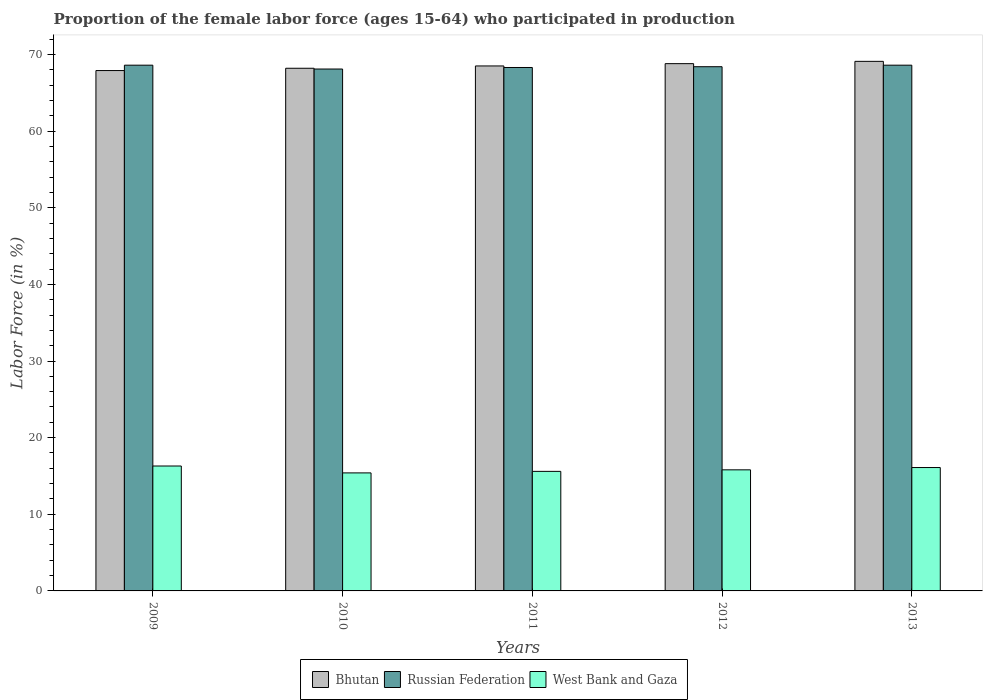How many different coloured bars are there?
Your answer should be compact. 3. How many groups of bars are there?
Your answer should be very brief. 5. How many bars are there on the 1st tick from the right?
Your response must be concise. 3. In how many cases, is the number of bars for a given year not equal to the number of legend labels?
Ensure brevity in your answer.  0. What is the proportion of the female labor force who participated in production in Russian Federation in 2012?
Provide a succinct answer. 68.4. Across all years, what is the maximum proportion of the female labor force who participated in production in Bhutan?
Your answer should be compact. 69.1. Across all years, what is the minimum proportion of the female labor force who participated in production in Russian Federation?
Give a very brief answer. 68.1. In which year was the proportion of the female labor force who participated in production in Russian Federation maximum?
Provide a succinct answer. 2009. In which year was the proportion of the female labor force who participated in production in West Bank and Gaza minimum?
Make the answer very short. 2010. What is the total proportion of the female labor force who participated in production in Russian Federation in the graph?
Offer a terse response. 342. What is the difference between the proportion of the female labor force who participated in production in Bhutan in 2011 and that in 2013?
Provide a short and direct response. -0.6. What is the difference between the proportion of the female labor force who participated in production in Bhutan in 2011 and the proportion of the female labor force who participated in production in West Bank and Gaza in 2013?
Make the answer very short. 52.4. What is the average proportion of the female labor force who participated in production in West Bank and Gaza per year?
Provide a short and direct response. 15.84. In the year 2009, what is the difference between the proportion of the female labor force who participated in production in West Bank and Gaza and proportion of the female labor force who participated in production in Russian Federation?
Make the answer very short. -52.3. What is the ratio of the proportion of the female labor force who participated in production in West Bank and Gaza in 2009 to that in 2010?
Provide a succinct answer. 1.06. Is the proportion of the female labor force who participated in production in Russian Federation in 2010 less than that in 2013?
Offer a very short reply. Yes. What is the difference between the highest and the second highest proportion of the female labor force who participated in production in West Bank and Gaza?
Keep it short and to the point. 0.2. What is the difference between the highest and the lowest proportion of the female labor force who participated in production in Russian Federation?
Make the answer very short. 0.5. What does the 3rd bar from the left in 2011 represents?
Ensure brevity in your answer.  West Bank and Gaza. What does the 3rd bar from the right in 2012 represents?
Your answer should be compact. Bhutan. Is it the case that in every year, the sum of the proportion of the female labor force who participated in production in West Bank and Gaza and proportion of the female labor force who participated in production in Russian Federation is greater than the proportion of the female labor force who participated in production in Bhutan?
Your response must be concise. Yes. How many bars are there?
Give a very brief answer. 15. How many years are there in the graph?
Keep it short and to the point. 5. Are the values on the major ticks of Y-axis written in scientific E-notation?
Your answer should be compact. No. Does the graph contain any zero values?
Offer a terse response. No. Does the graph contain grids?
Make the answer very short. No. How many legend labels are there?
Give a very brief answer. 3. What is the title of the graph?
Give a very brief answer. Proportion of the female labor force (ages 15-64) who participated in production. What is the label or title of the Y-axis?
Provide a succinct answer. Labor Force (in %). What is the Labor Force (in %) of Bhutan in 2009?
Keep it short and to the point. 67.9. What is the Labor Force (in %) in Russian Federation in 2009?
Your answer should be compact. 68.6. What is the Labor Force (in %) of West Bank and Gaza in 2009?
Make the answer very short. 16.3. What is the Labor Force (in %) of Bhutan in 2010?
Your response must be concise. 68.2. What is the Labor Force (in %) of Russian Federation in 2010?
Your response must be concise. 68.1. What is the Labor Force (in %) of West Bank and Gaza in 2010?
Provide a succinct answer. 15.4. What is the Labor Force (in %) of Bhutan in 2011?
Provide a short and direct response. 68.5. What is the Labor Force (in %) of Russian Federation in 2011?
Your response must be concise. 68.3. What is the Labor Force (in %) in West Bank and Gaza in 2011?
Give a very brief answer. 15.6. What is the Labor Force (in %) of Bhutan in 2012?
Keep it short and to the point. 68.8. What is the Labor Force (in %) of Russian Federation in 2012?
Your answer should be compact. 68.4. What is the Labor Force (in %) of West Bank and Gaza in 2012?
Your answer should be very brief. 15.8. What is the Labor Force (in %) in Bhutan in 2013?
Give a very brief answer. 69.1. What is the Labor Force (in %) of Russian Federation in 2013?
Give a very brief answer. 68.6. What is the Labor Force (in %) of West Bank and Gaza in 2013?
Provide a succinct answer. 16.1. Across all years, what is the maximum Labor Force (in %) of Bhutan?
Your response must be concise. 69.1. Across all years, what is the maximum Labor Force (in %) of Russian Federation?
Your answer should be very brief. 68.6. Across all years, what is the maximum Labor Force (in %) of West Bank and Gaza?
Ensure brevity in your answer.  16.3. Across all years, what is the minimum Labor Force (in %) in Bhutan?
Give a very brief answer. 67.9. Across all years, what is the minimum Labor Force (in %) of Russian Federation?
Your answer should be compact. 68.1. Across all years, what is the minimum Labor Force (in %) in West Bank and Gaza?
Offer a terse response. 15.4. What is the total Labor Force (in %) of Bhutan in the graph?
Your response must be concise. 342.5. What is the total Labor Force (in %) in Russian Federation in the graph?
Keep it short and to the point. 342. What is the total Labor Force (in %) in West Bank and Gaza in the graph?
Provide a succinct answer. 79.2. What is the difference between the Labor Force (in %) in Bhutan in 2009 and that in 2010?
Provide a succinct answer. -0.3. What is the difference between the Labor Force (in %) in Russian Federation in 2009 and that in 2010?
Your answer should be compact. 0.5. What is the difference between the Labor Force (in %) of West Bank and Gaza in 2009 and that in 2010?
Your answer should be compact. 0.9. What is the difference between the Labor Force (in %) of Russian Federation in 2009 and that in 2011?
Provide a succinct answer. 0.3. What is the difference between the Labor Force (in %) of West Bank and Gaza in 2009 and that in 2011?
Provide a short and direct response. 0.7. What is the difference between the Labor Force (in %) of Bhutan in 2009 and that in 2012?
Your response must be concise. -0.9. What is the difference between the Labor Force (in %) in Russian Federation in 2009 and that in 2012?
Offer a very short reply. 0.2. What is the difference between the Labor Force (in %) in West Bank and Gaza in 2009 and that in 2013?
Provide a short and direct response. 0.2. What is the difference between the Labor Force (in %) in Bhutan in 2010 and that in 2012?
Offer a terse response. -0.6. What is the difference between the Labor Force (in %) in Russian Federation in 2010 and that in 2012?
Make the answer very short. -0.3. What is the difference between the Labor Force (in %) of Bhutan in 2010 and that in 2013?
Offer a terse response. -0.9. What is the difference between the Labor Force (in %) of Russian Federation in 2010 and that in 2013?
Make the answer very short. -0.5. What is the difference between the Labor Force (in %) in Bhutan in 2011 and that in 2012?
Your response must be concise. -0.3. What is the difference between the Labor Force (in %) in West Bank and Gaza in 2011 and that in 2012?
Your answer should be compact. -0.2. What is the difference between the Labor Force (in %) in Russian Federation in 2011 and that in 2013?
Keep it short and to the point. -0.3. What is the difference between the Labor Force (in %) of West Bank and Gaza in 2011 and that in 2013?
Provide a short and direct response. -0.5. What is the difference between the Labor Force (in %) of Bhutan in 2012 and that in 2013?
Your answer should be compact. -0.3. What is the difference between the Labor Force (in %) in Russian Federation in 2012 and that in 2013?
Offer a terse response. -0.2. What is the difference between the Labor Force (in %) of Bhutan in 2009 and the Labor Force (in %) of Russian Federation in 2010?
Ensure brevity in your answer.  -0.2. What is the difference between the Labor Force (in %) in Bhutan in 2009 and the Labor Force (in %) in West Bank and Gaza in 2010?
Offer a very short reply. 52.5. What is the difference between the Labor Force (in %) of Russian Federation in 2009 and the Labor Force (in %) of West Bank and Gaza in 2010?
Provide a short and direct response. 53.2. What is the difference between the Labor Force (in %) in Bhutan in 2009 and the Labor Force (in %) in Russian Federation in 2011?
Keep it short and to the point. -0.4. What is the difference between the Labor Force (in %) in Bhutan in 2009 and the Labor Force (in %) in West Bank and Gaza in 2011?
Offer a terse response. 52.3. What is the difference between the Labor Force (in %) in Bhutan in 2009 and the Labor Force (in %) in West Bank and Gaza in 2012?
Offer a terse response. 52.1. What is the difference between the Labor Force (in %) in Russian Federation in 2009 and the Labor Force (in %) in West Bank and Gaza in 2012?
Ensure brevity in your answer.  52.8. What is the difference between the Labor Force (in %) of Bhutan in 2009 and the Labor Force (in %) of West Bank and Gaza in 2013?
Give a very brief answer. 51.8. What is the difference between the Labor Force (in %) of Russian Federation in 2009 and the Labor Force (in %) of West Bank and Gaza in 2013?
Offer a very short reply. 52.5. What is the difference between the Labor Force (in %) in Bhutan in 2010 and the Labor Force (in %) in West Bank and Gaza in 2011?
Your answer should be very brief. 52.6. What is the difference between the Labor Force (in %) in Russian Federation in 2010 and the Labor Force (in %) in West Bank and Gaza in 2011?
Your answer should be very brief. 52.5. What is the difference between the Labor Force (in %) in Bhutan in 2010 and the Labor Force (in %) in Russian Federation in 2012?
Offer a terse response. -0.2. What is the difference between the Labor Force (in %) of Bhutan in 2010 and the Labor Force (in %) of West Bank and Gaza in 2012?
Your answer should be compact. 52.4. What is the difference between the Labor Force (in %) of Russian Federation in 2010 and the Labor Force (in %) of West Bank and Gaza in 2012?
Your answer should be compact. 52.3. What is the difference between the Labor Force (in %) of Bhutan in 2010 and the Labor Force (in %) of West Bank and Gaza in 2013?
Ensure brevity in your answer.  52.1. What is the difference between the Labor Force (in %) in Russian Federation in 2010 and the Labor Force (in %) in West Bank and Gaza in 2013?
Your answer should be compact. 52. What is the difference between the Labor Force (in %) of Bhutan in 2011 and the Labor Force (in %) of West Bank and Gaza in 2012?
Make the answer very short. 52.7. What is the difference between the Labor Force (in %) in Russian Federation in 2011 and the Labor Force (in %) in West Bank and Gaza in 2012?
Offer a very short reply. 52.5. What is the difference between the Labor Force (in %) of Bhutan in 2011 and the Labor Force (in %) of West Bank and Gaza in 2013?
Your answer should be very brief. 52.4. What is the difference between the Labor Force (in %) in Russian Federation in 2011 and the Labor Force (in %) in West Bank and Gaza in 2013?
Give a very brief answer. 52.2. What is the difference between the Labor Force (in %) of Bhutan in 2012 and the Labor Force (in %) of West Bank and Gaza in 2013?
Offer a very short reply. 52.7. What is the difference between the Labor Force (in %) in Russian Federation in 2012 and the Labor Force (in %) in West Bank and Gaza in 2013?
Offer a very short reply. 52.3. What is the average Labor Force (in %) of Bhutan per year?
Your response must be concise. 68.5. What is the average Labor Force (in %) of Russian Federation per year?
Make the answer very short. 68.4. What is the average Labor Force (in %) in West Bank and Gaza per year?
Give a very brief answer. 15.84. In the year 2009, what is the difference between the Labor Force (in %) of Bhutan and Labor Force (in %) of West Bank and Gaza?
Offer a terse response. 51.6. In the year 2009, what is the difference between the Labor Force (in %) of Russian Federation and Labor Force (in %) of West Bank and Gaza?
Ensure brevity in your answer.  52.3. In the year 2010, what is the difference between the Labor Force (in %) of Bhutan and Labor Force (in %) of West Bank and Gaza?
Provide a short and direct response. 52.8. In the year 2010, what is the difference between the Labor Force (in %) in Russian Federation and Labor Force (in %) in West Bank and Gaza?
Keep it short and to the point. 52.7. In the year 2011, what is the difference between the Labor Force (in %) in Bhutan and Labor Force (in %) in Russian Federation?
Offer a very short reply. 0.2. In the year 2011, what is the difference between the Labor Force (in %) of Bhutan and Labor Force (in %) of West Bank and Gaza?
Provide a short and direct response. 52.9. In the year 2011, what is the difference between the Labor Force (in %) of Russian Federation and Labor Force (in %) of West Bank and Gaza?
Ensure brevity in your answer.  52.7. In the year 2012, what is the difference between the Labor Force (in %) of Bhutan and Labor Force (in %) of West Bank and Gaza?
Offer a very short reply. 53. In the year 2012, what is the difference between the Labor Force (in %) in Russian Federation and Labor Force (in %) in West Bank and Gaza?
Offer a terse response. 52.6. In the year 2013, what is the difference between the Labor Force (in %) of Bhutan and Labor Force (in %) of Russian Federation?
Give a very brief answer. 0.5. In the year 2013, what is the difference between the Labor Force (in %) of Bhutan and Labor Force (in %) of West Bank and Gaza?
Give a very brief answer. 53. In the year 2013, what is the difference between the Labor Force (in %) of Russian Federation and Labor Force (in %) of West Bank and Gaza?
Offer a terse response. 52.5. What is the ratio of the Labor Force (in %) of Bhutan in 2009 to that in 2010?
Give a very brief answer. 1. What is the ratio of the Labor Force (in %) in Russian Federation in 2009 to that in 2010?
Your response must be concise. 1.01. What is the ratio of the Labor Force (in %) in West Bank and Gaza in 2009 to that in 2010?
Your answer should be very brief. 1.06. What is the ratio of the Labor Force (in %) in Bhutan in 2009 to that in 2011?
Offer a terse response. 0.99. What is the ratio of the Labor Force (in %) in Russian Federation in 2009 to that in 2011?
Offer a terse response. 1. What is the ratio of the Labor Force (in %) of West Bank and Gaza in 2009 to that in 2011?
Ensure brevity in your answer.  1.04. What is the ratio of the Labor Force (in %) in Bhutan in 2009 to that in 2012?
Ensure brevity in your answer.  0.99. What is the ratio of the Labor Force (in %) of West Bank and Gaza in 2009 to that in 2012?
Give a very brief answer. 1.03. What is the ratio of the Labor Force (in %) in Bhutan in 2009 to that in 2013?
Provide a succinct answer. 0.98. What is the ratio of the Labor Force (in %) of Russian Federation in 2009 to that in 2013?
Provide a short and direct response. 1. What is the ratio of the Labor Force (in %) of West Bank and Gaza in 2009 to that in 2013?
Your answer should be very brief. 1.01. What is the ratio of the Labor Force (in %) of Russian Federation in 2010 to that in 2011?
Ensure brevity in your answer.  1. What is the ratio of the Labor Force (in %) in West Bank and Gaza in 2010 to that in 2011?
Offer a terse response. 0.99. What is the ratio of the Labor Force (in %) in Bhutan in 2010 to that in 2012?
Offer a very short reply. 0.99. What is the ratio of the Labor Force (in %) in Russian Federation in 2010 to that in 2012?
Provide a succinct answer. 1. What is the ratio of the Labor Force (in %) in West Bank and Gaza in 2010 to that in 2012?
Your response must be concise. 0.97. What is the ratio of the Labor Force (in %) in Russian Federation in 2010 to that in 2013?
Your answer should be very brief. 0.99. What is the ratio of the Labor Force (in %) in West Bank and Gaza in 2010 to that in 2013?
Make the answer very short. 0.96. What is the ratio of the Labor Force (in %) of Bhutan in 2011 to that in 2012?
Your answer should be very brief. 1. What is the ratio of the Labor Force (in %) in West Bank and Gaza in 2011 to that in 2012?
Provide a short and direct response. 0.99. What is the ratio of the Labor Force (in %) in Bhutan in 2011 to that in 2013?
Your answer should be very brief. 0.99. What is the ratio of the Labor Force (in %) in West Bank and Gaza in 2011 to that in 2013?
Offer a very short reply. 0.97. What is the ratio of the Labor Force (in %) of Russian Federation in 2012 to that in 2013?
Keep it short and to the point. 1. What is the ratio of the Labor Force (in %) in West Bank and Gaza in 2012 to that in 2013?
Offer a very short reply. 0.98. What is the difference between the highest and the second highest Labor Force (in %) of Bhutan?
Your answer should be very brief. 0.3. What is the difference between the highest and the second highest Labor Force (in %) in West Bank and Gaza?
Offer a very short reply. 0.2. 